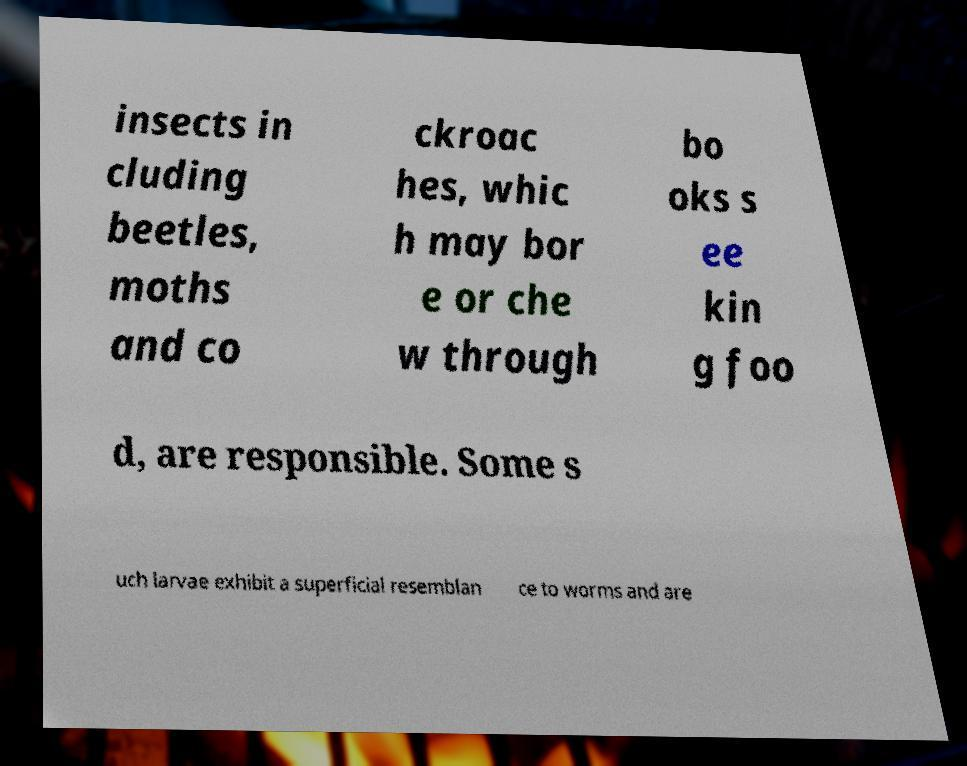I need the written content from this picture converted into text. Can you do that? insects in cluding beetles, moths and co ckroac hes, whic h may bor e or che w through bo oks s ee kin g foo d, are responsible. Some s uch larvae exhibit a superficial resemblan ce to worms and are 